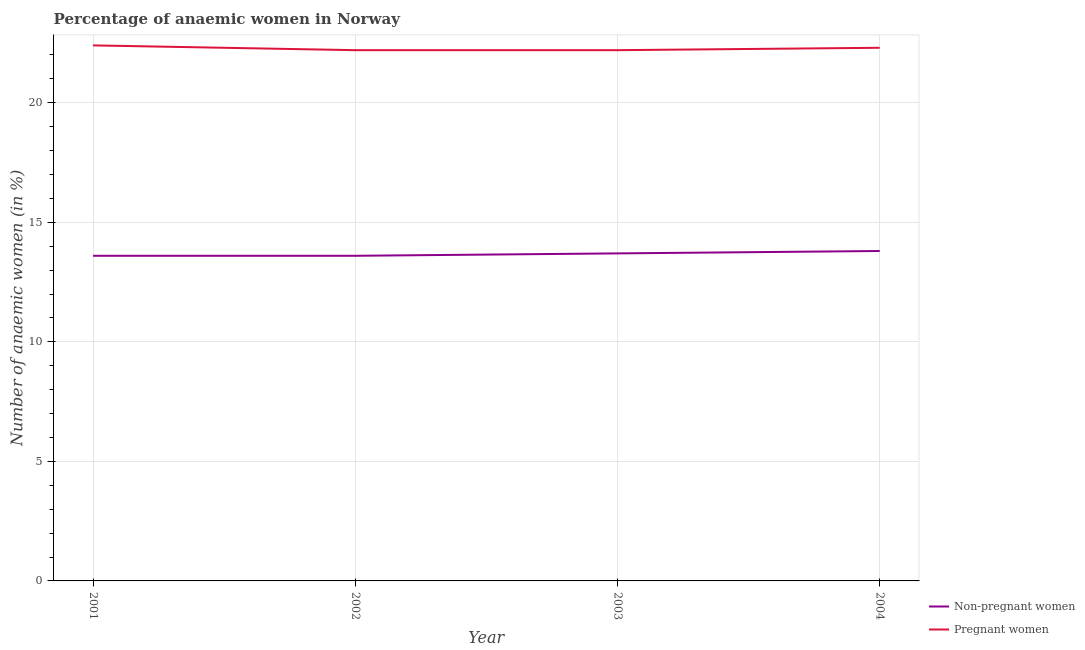How many different coloured lines are there?
Provide a short and direct response. 2. Does the line corresponding to percentage of non-pregnant anaemic women intersect with the line corresponding to percentage of pregnant anaemic women?
Provide a short and direct response. No. What is the percentage of pregnant anaemic women in 2004?
Offer a terse response. 22.3. Across all years, what is the maximum percentage of non-pregnant anaemic women?
Your answer should be very brief. 13.8. Across all years, what is the minimum percentage of non-pregnant anaemic women?
Make the answer very short. 13.6. In which year was the percentage of pregnant anaemic women maximum?
Keep it short and to the point. 2001. In which year was the percentage of pregnant anaemic women minimum?
Provide a succinct answer. 2002. What is the total percentage of pregnant anaemic women in the graph?
Keep it short and to the point. 89.1. What is the difference between the percentage of pregnant anaemic women in 2001 and that in 2003?
Provide a succinct answer. 0.2. What is the difference between the percentage of pregnant anaemic women in 2003 and the percentage of non-pregnant anaemic women in 2004?
Provide a short and direct response. 8.4. What is the average percentage of non-pregnant anaemic women per year?
Keep it short and to the point. 13.68. What is the ratio of the percentage of pregnant anaemic women in 2001 to that in 2002?
Your answer should be compact. 1.01. Is the difference between the percentage of non-pregnant anaemic women in 2003 and 2004 greater than the difference between the percentage of pregnant anaemic women in 2003 and 2004?
Provide a short and direct response. No. What is the difference between the highest and the second highest percentage of non-pregnant anaemic women?
Provide a short and direct response. 0.1. What is the difference between the highest and the lowest percentage of pregnant anaemic women?
Give a very brief answer. 0.2. In how many years, is the percentage of non-pregnant anaemic women greater than the average percentage of non-pregnant anaemic women taken over all years?
Offer a very short reply. 2. Is the percentage of pregnant anaemic women strictly greater than the percentage of non-pregnant anaemic women over the years?
Keep it short and to the point. Yes. How many lines are there?
Provide a succinct answer. 2. How many years are there in the graph?
Make the answer very short. 4. Does the graph contain any zero values?
Keep it short and to the point. No. Where does the legend appear in the graph?
Your answer should be very brief. Bottom right. How many legend labels are there?
Provide a succinct answer. 2. What is the title of the graph?
Offer a terse response. Percentage of anaemic women in Norway. Does "Technicians" appear as one of the legend labels in the graph?
Give a very brief answer. No. What is the label or title of the Y-axis?
Ensure brevity in your answer.  Number of anaemic women (in %). What is the Number of anaemic women (in %) of Pregnant women in 2001?
Provide a succinct answer. 22.4. What is the Number of anaemic women (in %) of Pregnant women in 2002?
Your answer should be very brief. 22.2. What is the Number of anaemic women (in %) in Non-pregnant women in 2003?
Offer a very short reply. 13.7. What is the Number of anaemic women (in %) of Pregnant women in 2004?
Offer a very short reply. 22.3. Across all years, what is the maximum Number of anaemic women (in %) in Non-pregnant women?
Make the answer very short. 13.8. Across all years, what is the maximum Number of anaemic women (in %) in Pregnant women?
Offer a terse response. 22.4. Across all years, what is the minimum Number of anaemic women (in %) in Non-pregnant women?
Make the answer very short. 13.6. What is the total Number of anaemic women (in %) of Non-pregnant women in the graph?
Give a very brief answer. 54.7. What is the total Number of anaemic women (in %) in Pregnant women in the graph?
Your answer should be very brief. 89.1. What is the difference between the Number of anaemic women (in %) of Non-pregnant women in 2001 and that in 2002?
Your response must be concise. 0. What is the difference between the Number of anaemic women (in %) of Pregnant women in 2001 and that in 2002?
Make the answer very short. 0.2. What is the difference between the Number of anaemic women (in %) of Pregnant women in 2001 and that in 2003?
Your answer should be compact. 0.2. What is the difference between the Number of anaemic women (in %) of Pregnant women in 2002 and that in 2003?
Give a very brief answer. 0. What is the difference between the Number of anaemic women (in %) in Non-pregnant women in 2002 and that in 2004?
Your answer should be very brief. -0.2. What is the difference between the Number of anaemic women (in %) of Pregnant women in 2002 and that in 2004?
Keep it short and to the point. -0.1. What is the difference between the Number of anaemic women (in %) in Non-pregnant women in 2003 and that in 2004?
Your answer should be very brief. -0.1. What is the difference between the Number of anaemic women (in %) in Non-pregnant women in 2001 and the Number of anaemic women (in %) in Pregnant women in 2003?
Ensure brevity in your answer.  -8.6. What is the average Number of anaemic women (in %) in Non-pregnant women per year?
Provide a succinct answer. 13.68. What is the average Number of anaemic women (in %) of Pregnant women per year?
Make the answer very short. 22.27. In the year 2002, what is the difference between the Number of anaemic women (in %) in Non-pregnant women and Number of anaemic women (in %) in Pregnant women?
Offer a terse response. -8.6. In the year 2003, what is the difference between the Number of anaemic women (in %) in Non-pregnant women and Number of anaemic women (in %) in Pregnant women?
Offer a very short reply. -8.5. In the year 2004, what is the difference between the Number of anaemic women (in %) in Non-pregnant women and Number of anaemic women (in %) in Pregnant women?
Make the answer very short. -8.5. What is the ratio of the Number of anaemic women (in %) of Pregnant women in 2001 to that in 2003?
Provide a succinct answer. 1.01. What is the ratio of the Number of anaemic women (in %) of Non-pregnant women in 2001 to that in 2004?
Your answer should be very brief. 0.99. What is the ratio of the Number of anaemic women (in %) in Pregnant women in 2001 to that in 2004?
Offer a very short reply. 1. What is the ratio of the Number of anaemic women (in %) of Non-pregnant women in 2002 to that in 2004?
Ensure brevity in your answer.  0.99. What is the ratio of the Number of anaemic women (in %) of Pregnant women in 2002 to that in 2004?
Offer a very short reply. 1. What is the ratio of the Number of anaemic women (in %) in Non-pregnant women in 2003 to that in 2004?
Your answer should be very brief. 0.99. What is the ratio of the Number of anaemic women (in %) in Pregnant women in 2003 to that in 2004?
Offer a terse response. 1. What is the difference between the highest and the second highest Number of anaemic women (in %) in Pregnant women?
Ensure brevity in your answer.  0.1. What is the difference between the highest and the lowest Number of anaemic women (in %) in Non-pregnant women?
Offer a terse response. 0.2. 